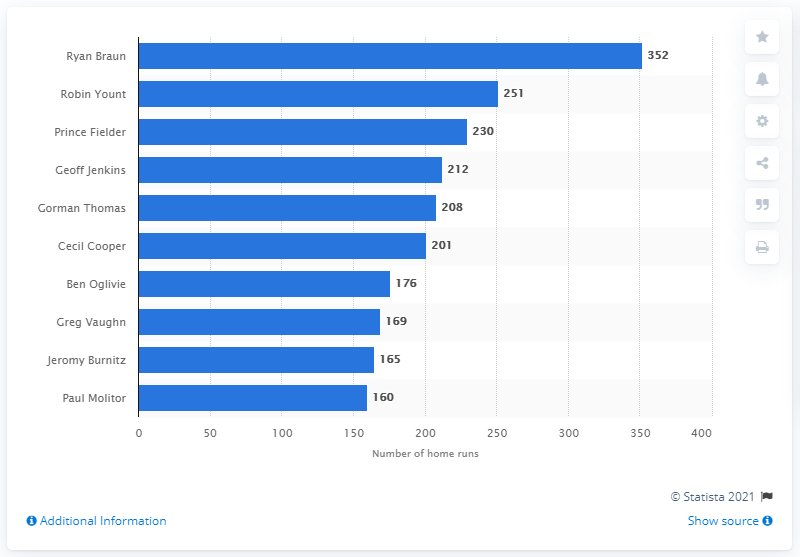Specify some key components in this picture. Ryan Braun has hit a total of 352 home runs in his career. The Milwaukee Brewers franchise has seen many talented players hit home runs throughout their storied history, but none have hit more than Ryan Braun. 